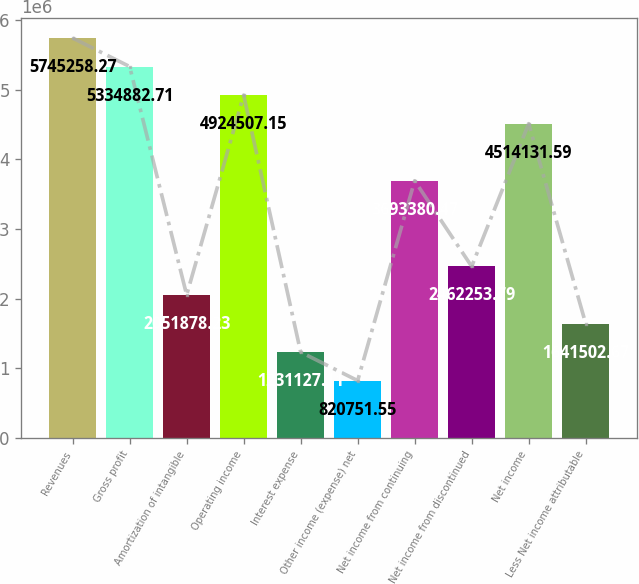Convert chart. <chart><loc_0><loc_0><loc_500><loc_500><bar_chart><fcel>Revenues<fcel>Gross profit<fcel>Amortization of intangible<fcel>Operating income<fcel>Interest expense<fcel>Other income (expense) net<fcel>Net income from continuing<fcel>Net income from discontinued<fcel>Net income<fcel>Less Net income attributable<nl><fcel>5.74526e+06<fcel>5.33488e+06<fcel>2.05188e+06<fcel>4.92451e+06<fcel>1.23113e+06<fcel>820752<fcel>3.69338e+06<fcel>2.46225e+06<fcel>4.51413e+06<fcel>1.6415e+06<nl></chart> 